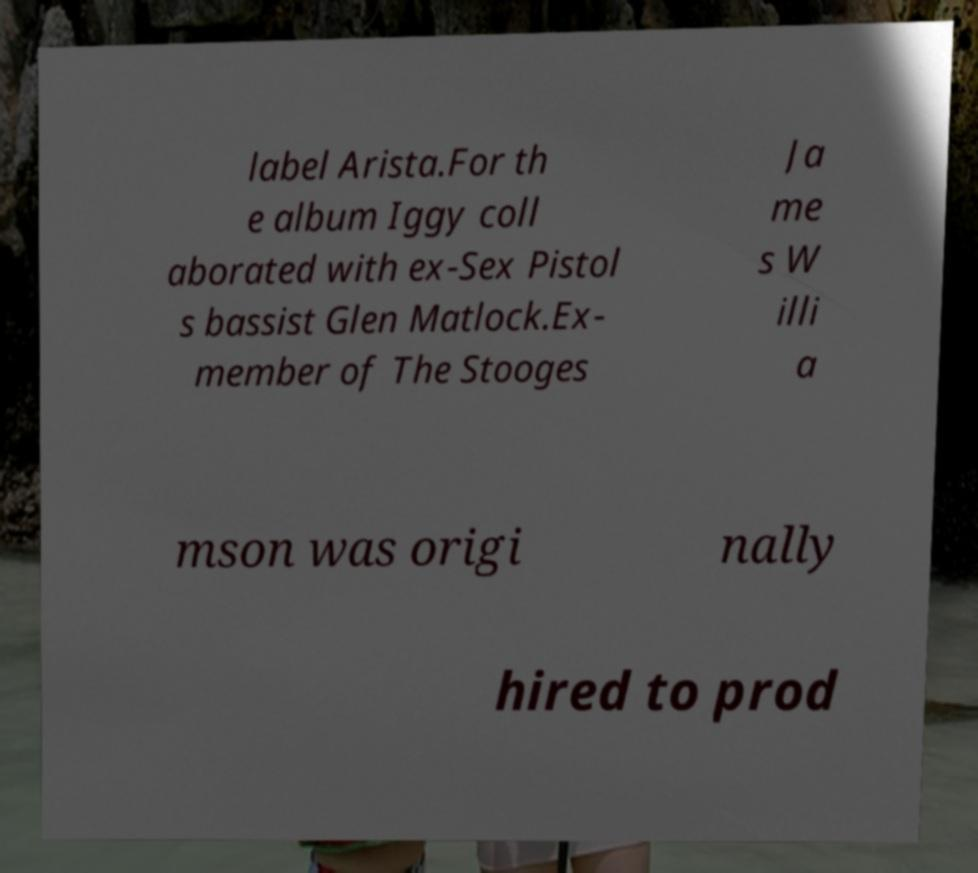Please read and relay the text visible in this image. What does it say? label Arista.For th e album Iggy coll aborated with ex-Sex Pistol s bassist Glen Matlock.Ex- member of The Stooges Ja me s W illi a mson was origi nally hired to prod 